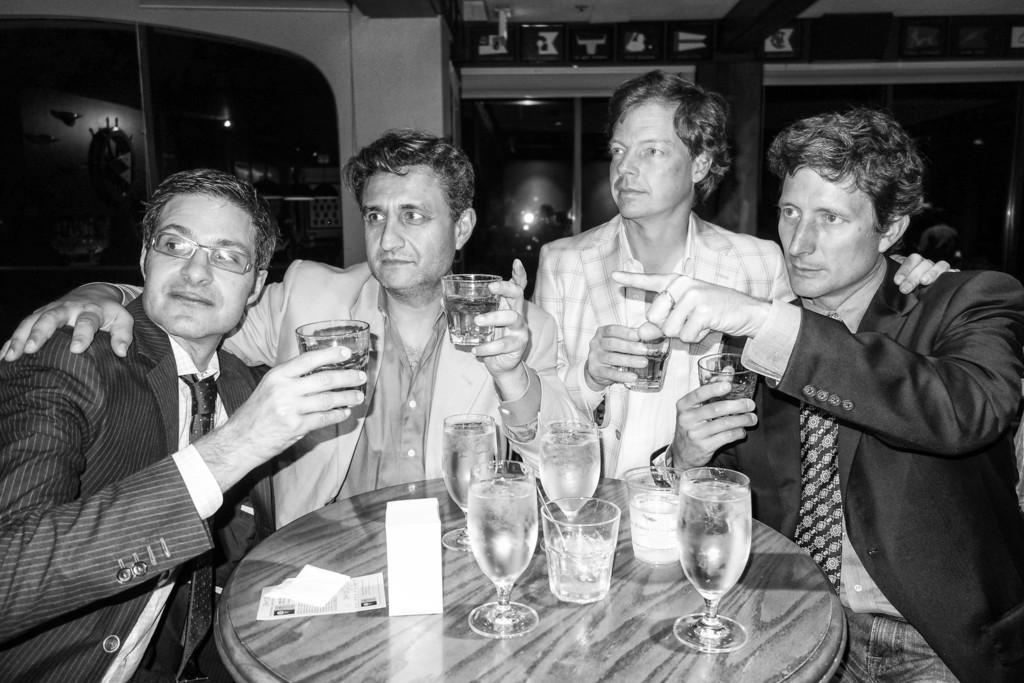How many people are in the image? There are four persons in the image. What are the persons holding in their hands? Each person is holding a wine glass. What is present in front of the persons? There is a table in front of the persons. What can be seen on the table? The table has a glass of wine on it. What type of steam is coming from the wine glasses in the image? There is no steam coming from the wine glasses in the image. What is the shape of the curve on the table in the image? There is no curve mentioned or visible on the table in the image. 